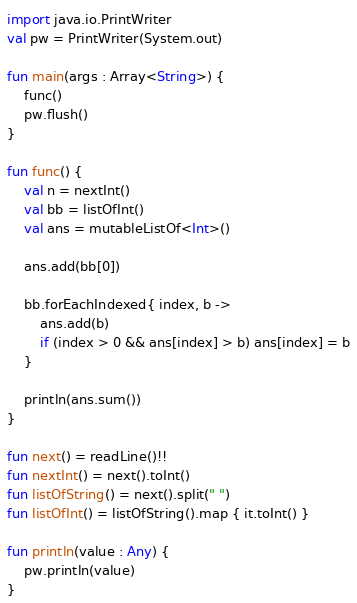Convert code to text. <code><loc_0><loc_0><loc_500><loc_500><_Kotlin_>import java.io.PrintWriter
val pw = PrintWriter(System.out)

fun main(args : Array<String>) {
    func()
    pw.flush()
}

fun func() {
    val n = nextInt()
    val bb = listOfInt()
    val ans = mutableListOf<Int>()

    ans.add(bb[0])

    bb.forEachIndexed{ index, b ->
        ans.add(b)
        if (index > 0 && ans[index] > b) ans[index] = b
    }

    println(ans.sum())
}

fun next() = readLine()!!
fun nextInt() = next().toInt()
fun listOfString() = next().split(" ")
fun listOfInt() = listOfString().map { it.toInt() }

fun println(value : Any) {
    pw.println(value)
}</code> 